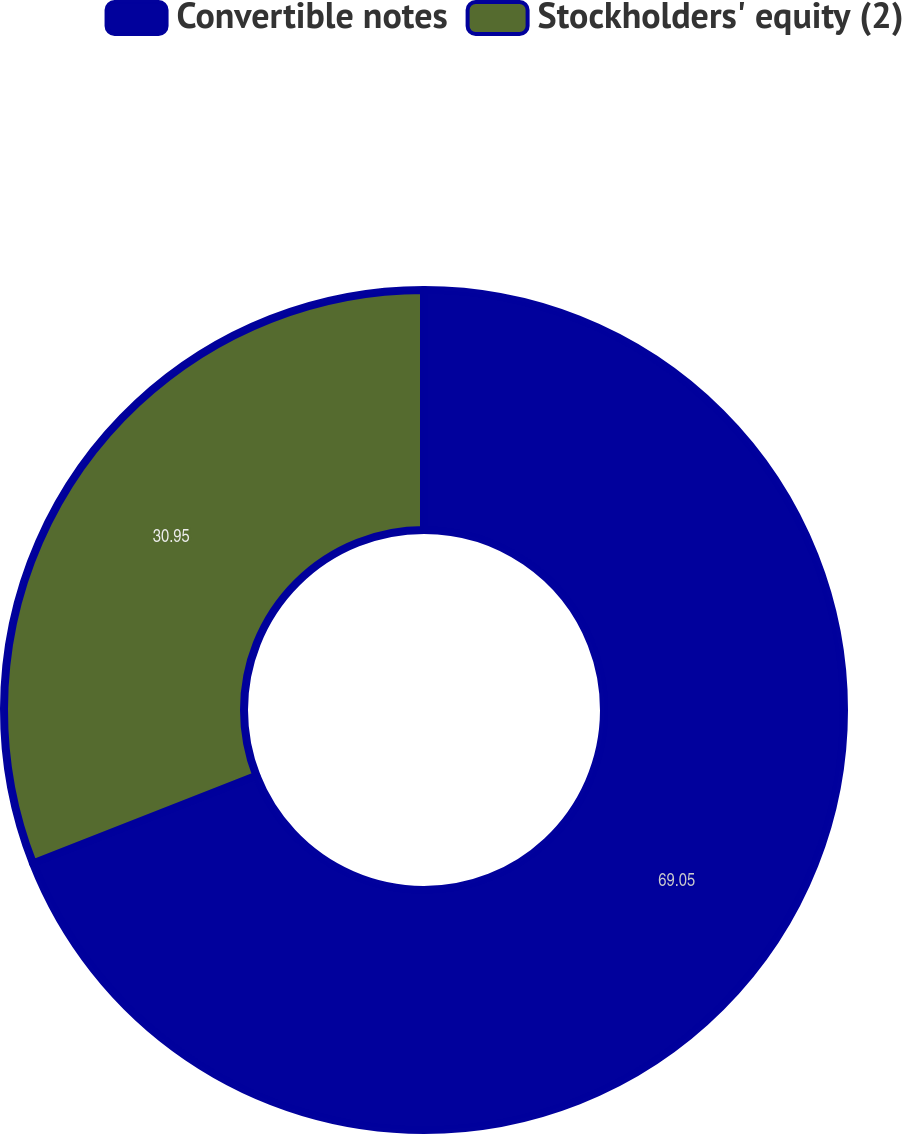Convert chart to OTSL. <chart><loc_0><loc_0><loc_500><loc_500><pie_chart><fcel>Convertible notes<fcel>Stockholders' equity (2)<nl><fcel>69.05%<fcel>30.95%<nl></chart> 